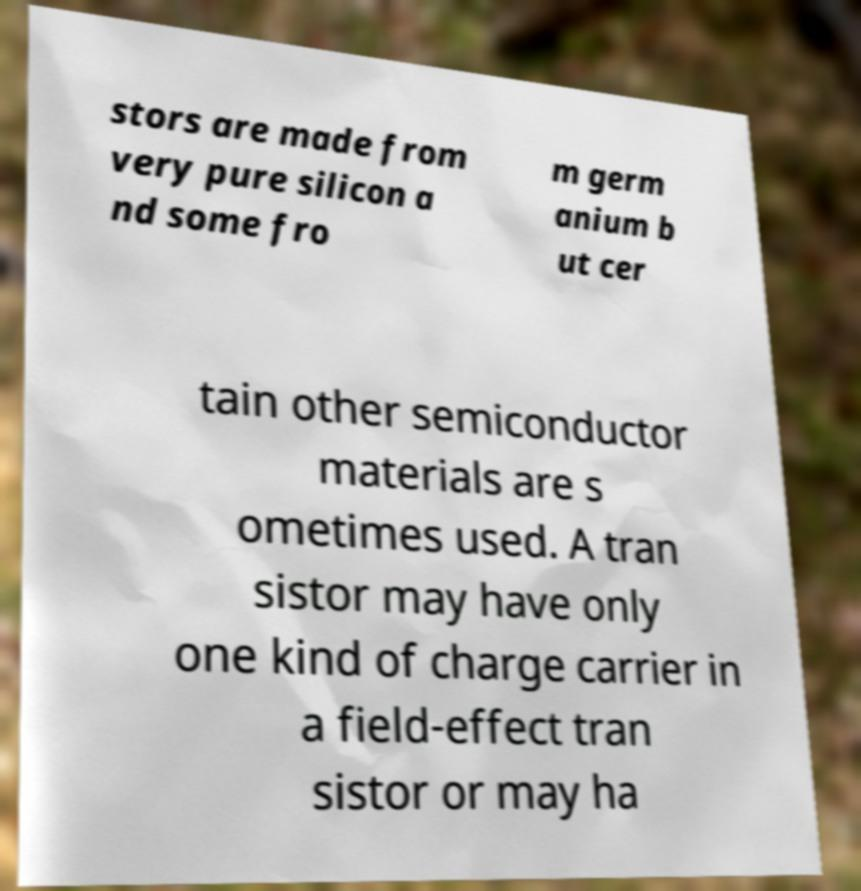Could you extract and type out the text from this image? stors are made from very pure silicon a nd some fro m germ anium b ut cer tain other semiconductor materials are s ometimes used. A tran sistor may have only one kind of charge carrier in a field-effect tran sistor or may ha 